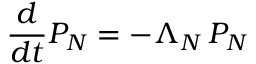<formula> <loc_0><loc_0><loc_500><loc_500>{ \frac { d } { d t } } P _ { N } = - \Lambda _ { N } \, P _ { N }</formula> 